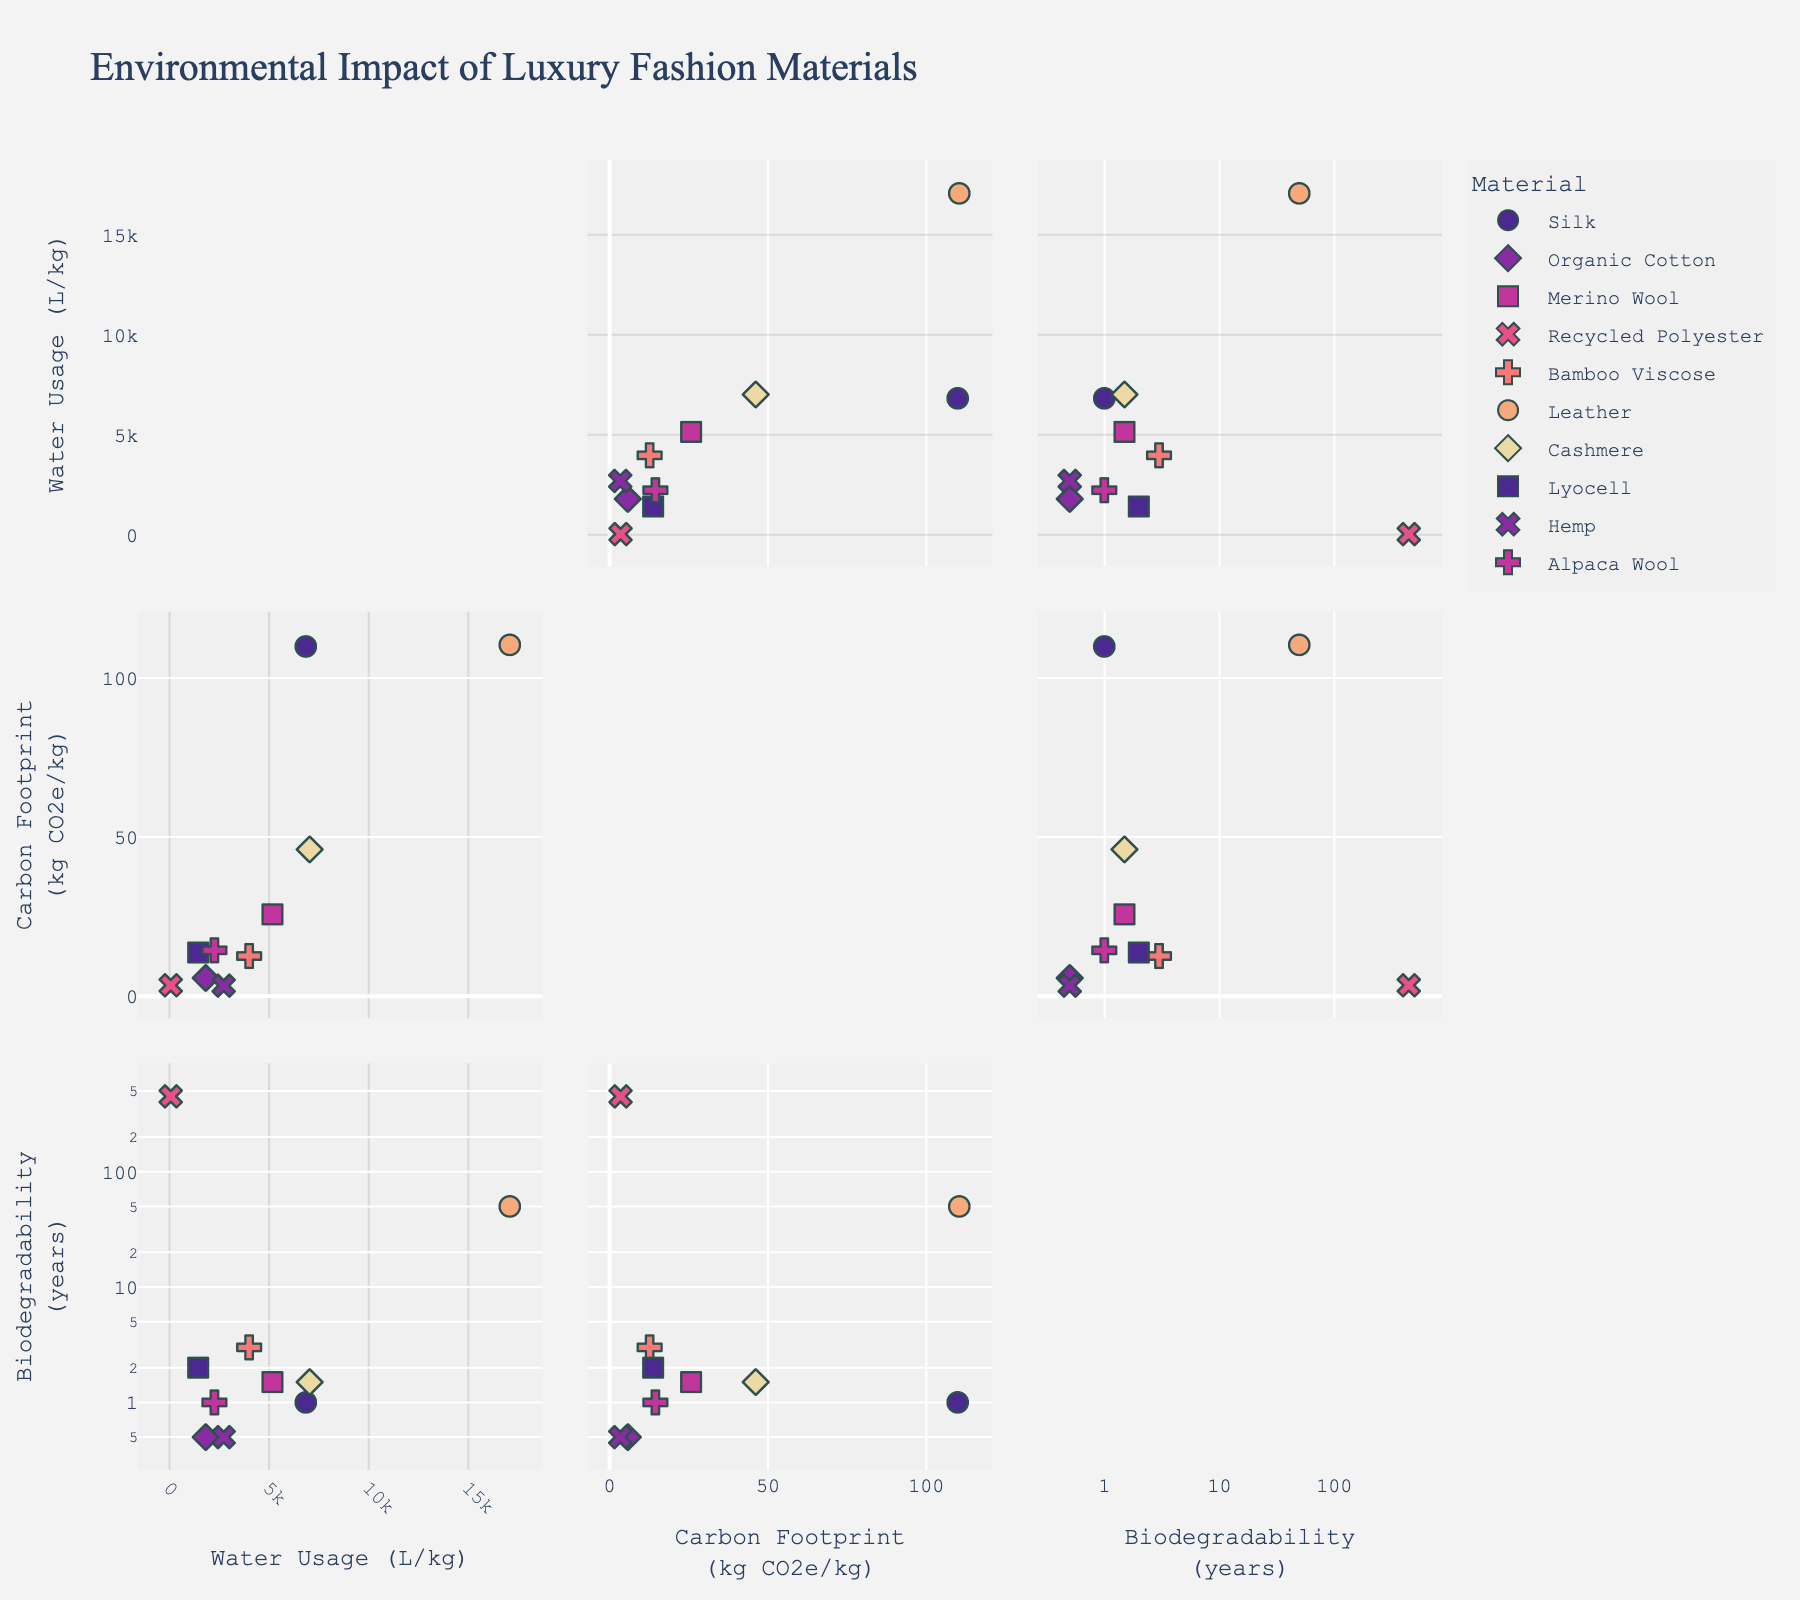What's the title of the plot? The title appears at the top of the plot and reads "Environmental Impact of Luxury Fashion Materials."
Answer: Environmental Impact of Luxury Fashion Materials How many different materials are represented in the scatterplot matrix? Each material has a unique color and symbol in the scatterplot. By counting the different colors and symbols, we see there are 10 different materials.
Answer: 10 Which material has the highest water usage? Look at the scatterplot points along the 'Water Usage (L/kg)' axis. The highest point is labeled as 'Leather'.
Answer: Leather Which materials have a biodegradability of 0.5 years? Find the points on the 'Biodegradability (years)' axis that correspond to 0.5 years and see that they are labeled 'Organic Cotton' and 'Hemp'.
Answer: Organic Cotton, Hemp What is the range of carbon footprint values among the materials? Identify the lowest and highest points along the 'Carbon Footprint (kg CO2e/kg)' axis. The lowest value is 3.4 (Hemp) and the highest is 110.5 (Leather).
Answer: 3.4 to 110.5 Which material has the shortest biodegradability and what is its carbon footprint? The shortest biodegradability is 0.5 years (from a previous answer). The materials with 0.5 years are 'Organic Cotton' and 'Hemp'. Their carbon footprints are 5.8 and 3.4 kg CO2e/kg respectively.
Answer: Organic Cotton: 5.8, Hemp: 3.4 What is the average carbon footprint of materials with water usage over 5000 L/kg? Identify materials with water usage over 5000 L/kg (Silk, Merino Wool, Leather, Cashmere). Their carbon footprints are 110, 25.8, 110.5, 46.2 kg CO2e/kg respectively. The average is (110 + 25.8 + 110.5 + 46.2) / 4.
Answer: 73.13 Which materials have a higher carbon footprint than biodegradability? Compare values on the 'Carbon Footprint (kg CO2e/kg)' and 'Biodegradability (years)' axes. 'Leather', 'Silk', 'Cashmere', 'Lyocell', and 'Alpaca Wool' have higher carbon footprints than biodegradability years.
Answer: Leather, Silk, Cashmere, Lyocell, Alpaca Wool Which pair of materials have the closest water usage values but vastly different biodegradability? Compare points on the 'Water Usage (L/kg)' axis that are close together. 'Cashmere' (7040 L/kg) and 'Silk' (6847 L/kg) are close in water usage but differ in biodegradability (Silk: 1 year, Cashmere: 1.5 years).
Answer: Cashmere and Silk In a comparison of biodegradability, which material degrades slower than Bamboo Viscose but faster than Leather? Find materials with biodegradability between 3 years (Bamboo Viscose) and 50 years (Leather). 'Lyocell' (2 years) falls between these two values.
Answer: Lyocell 